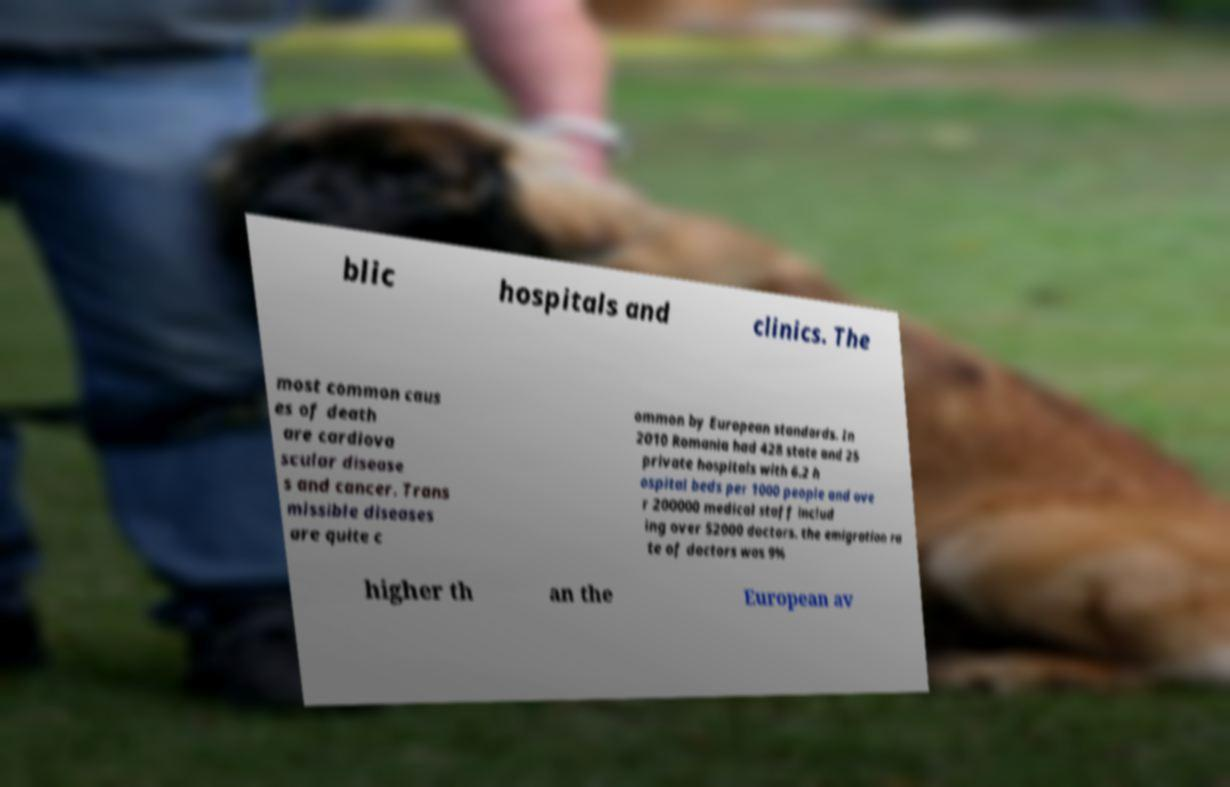Please read and relay the text visible in this image. What does it say? blic hospitals and clinics. The most common caus es of death are cardiova scular disease s and cancer. Trans missible diseases are quite c ommon by European standards. In 2010 Romania had 428 state and 25 private hospitals with 6.2 h ospital beds per 1000 people and ove r 200000 medical staff includ ing over 52000 doctors. the emigration ra te of doctors was 9% higher th an the European av 